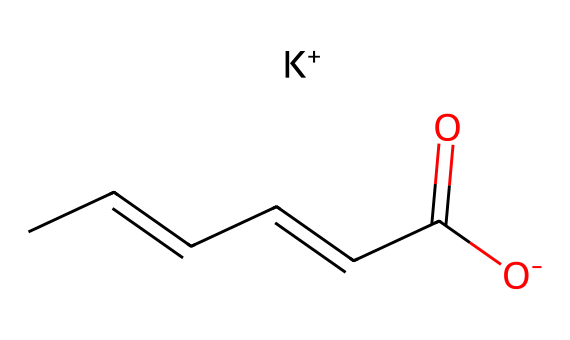What is the functional group present in potassium sorbate? The functional group can be identified by looking at the part of the molecule containing the carbonyl group (C=O) directly adjacent to the hydroxyl group (OH). This combination indicates a carboxylate (-COO-) functional group due to its structure as a potassium salt.
Answer: carboxylate How many carbon atoms are in the structure of potassium sorbate? By examining the SMILES representation, there are six 'C' characters, indicating six carbon atoms in total.
Answer: six How does potassium sorbate exist in solution? The potassium sorbate in the provided SMILES shows that it is represented as a carboxylate ion (O- with K+ as a counterion), indicating that it exists as a salt in aqueous solution.
Answer: as a salt What is the total number of atoms in potassium sorbate? Adding the atoms together from the SMILES representation: six carbons, eight hydrogens, two oxygens, and one potassium, resulting in a total of seventeen atoms.
Answer: seventeen What type of compound is potassium sorbate categorized as? Given that it is used as a preservative and has a specific functional group that inhibits microbial growth, it is categorized as a preservative compound.
Answer: preservative What element serves as a counterion in potassium sorbate? The potassium ion (K+) is indicated as part of the SMILES representation, serving as the counterion to the carboxylate.
Answer: potassium 